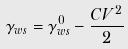<formula> <loc_0><loc_0><loc_500><loc_500>\gamma _ { w s } = \gamma _ { w s } ^ { 0 } - \frac { C V ^ { 2 } } { 2 }</formula> 